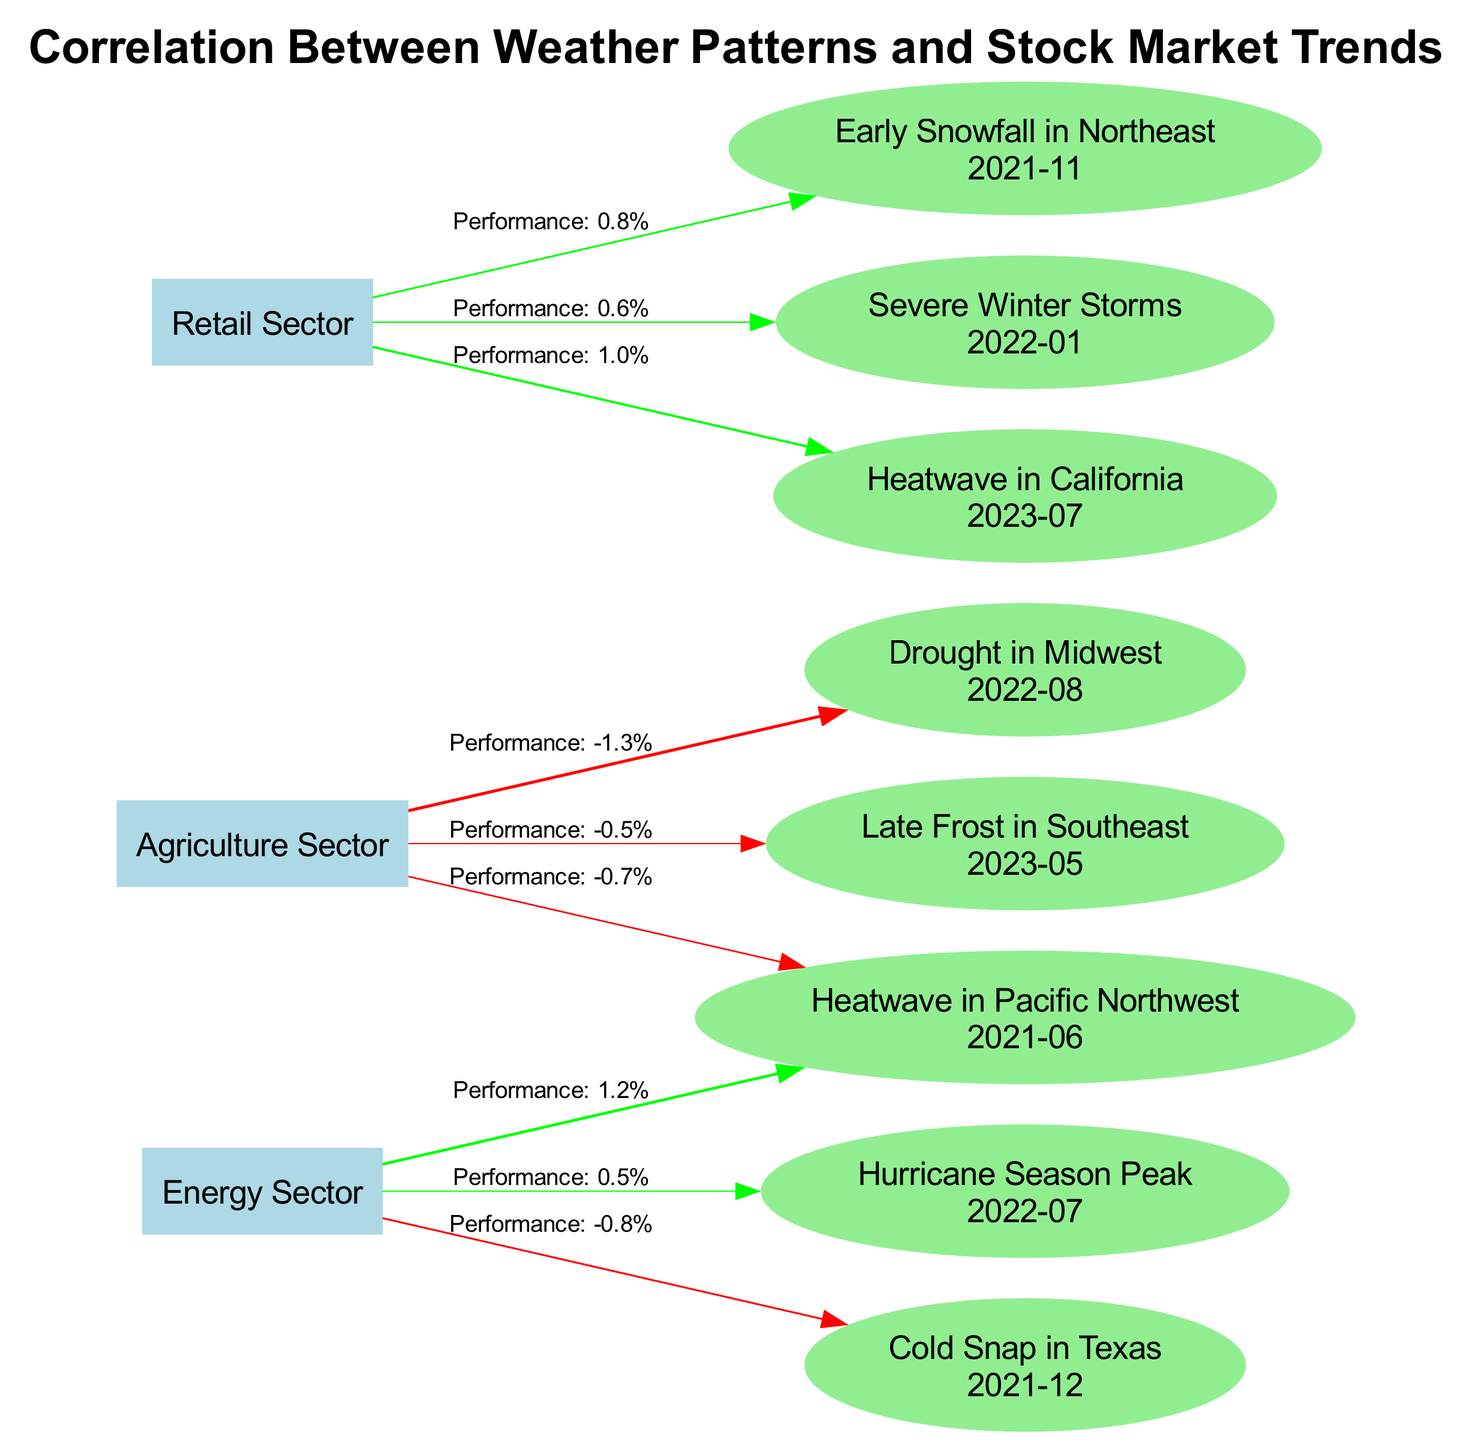What is the performance percentage for the Energy Sector after the cold snap in Texas? According to the diagram, after the event labeled "Cold Snap in Texas" in December 2021, the performance for the Energy Sector is -0.8%.
Answer: -0.8% Which event caused the most negative impact on the Agriculture Sector? The event with the most negative impact on the Agriculture Sector is "Drought in Midwest" in August 2022, with a performance of -1.3%.
Answer: Drought in Midwest What was the performance change for the Retail Sector between January 2022 and July 2023? The performance for the Retail Sector in January 2022 was 0.6% from "Severe Winter Storms" and increased to 1.0% after "Heatwave in California" in July 2023, indicating a positive change of 0.4%.
Answer: 0.4% How many distinct weather events were recorded for the Energy Sector in the last five years? The diagram shows three distinct weather events for the Energy Sector: "Heatwave in Pacific Northwest", "Cold Snap in Texas", and "Hurricane Season Peak".
Answer: 3 Which weather event had a positive effect on stock market performance in the Agriculture Sector? Based on the diagram, there are no weather events causing positive performance in the Agriculture Sector. All listed events resulted in negative performance.
Answer: None What is the performance trend of the Retail Sector between November 2021 and May 2023? The trend shows a positive performance starting at 0.8% in November 2021 and fluctuating slightly, with a performance of 1.0% by July 2023, indicating a generally upward trend.
Answer: Upward trend Which sector was most negatively affected by the heatwave in June 2021? The Agriculture Sector was most negatively affected by the heatwave in June 2021, recording a performance of -0.7%.
Answer: Agriculture Sector How does the performance of the Energy Sector compare between the heatwave and the hurricane season peak? The performance changed from 1.2% during the "Heatwave in Pacific Northwest" to 0.5% during the "Hurricane Season Peak", indicating a decrease of 0.7%.
Answer: Decrease of 0.7% What was the stock market performance in the Retail Sector following early snowfall in November 2021? After the "Early Snowfall in Northeast" in November 2021, the stock market performance for the Retail Sector was recorded at 0.8%.
Answer: 0.8% 